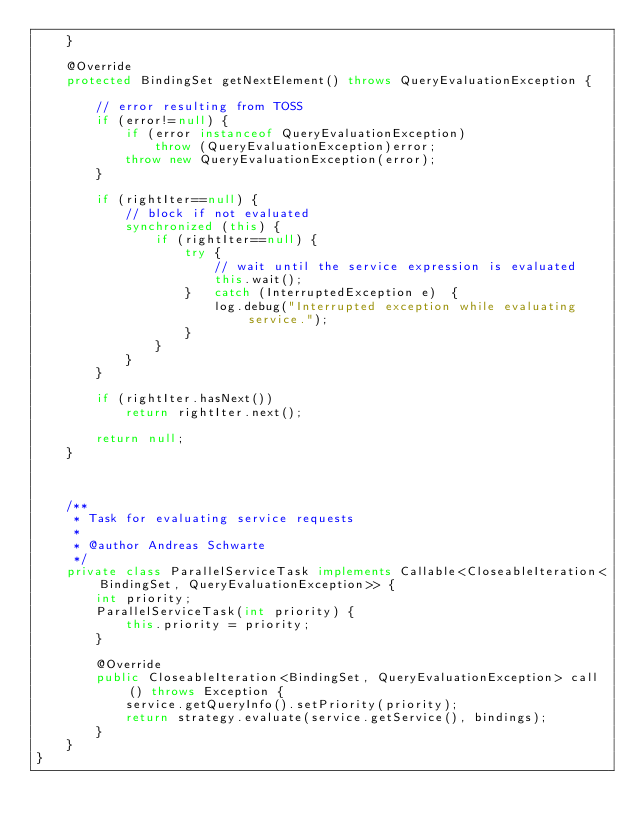Convert code to text. <code><loc_0><loc_0><loc_500><loc_500><_Java_>	}

	@Override
	protected BindingSet getNextElement() throws QueryEvaluationException {
		
		// error resulting from TOSS
		if (error!=null) {
			if (error instanceof QueryEvaluationException)
				throw (QueryEvaluationException)error;
			throw new QueryEvaluationException(error);
		}
			
		if (rightIter==null) {	
			// block if not evaluated
			synchronized (this) {
				if (rightIter==null) {
					try	{
						// wait until the service expression is evaluated
						this.wait();
					}	catch (InterruptedException e)	{
						log.debug("Interrupted exception while evaluating service.");
					}
				}
			}
		}
		
		if (rightIter.hasNext())
			return rightIter.next();		
		
		return null;
	}


	
	/**
	 * Task for evaluating service requests
	 * 
	 * @author Andreas Schwarte
	 */
	private class ParallelServiceTask implements Callable<CloseableIteration<BindingSet, QueryEvaluationException>> {
		int priority;
		ParallelServiceTask(int priority) {
			this.priority = priority;
		}
		
		@Override
		public CloseableIteration<BindingSet, QueryEvaluationException> call() throws Exception {
			service.getQueryInfo().setPriority(priority);
			return strategy.evaluate(service.getService(), bindings);
		}
	}
}
</code> 